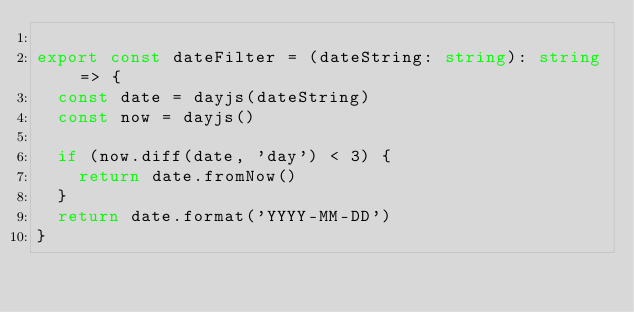Convert code to text. <code><loc_0><loc_0><loc_500><loc_500><_TypeScript_>
export const dateFilter = (dateString: string): string => {
  const date = dayjs(dateString)
  const now = dayjs()

  if (now.diff(date, 'day') < 3) {
    return date.fromNow()
  }
  return date.format('YYYY-MM-DD')
}

</code> 